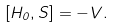Convert formula to latex. <formula><loc_0><loc_0><loc_500><loc_500>[ H _ { 0 } , S ] = - V .</formula> 